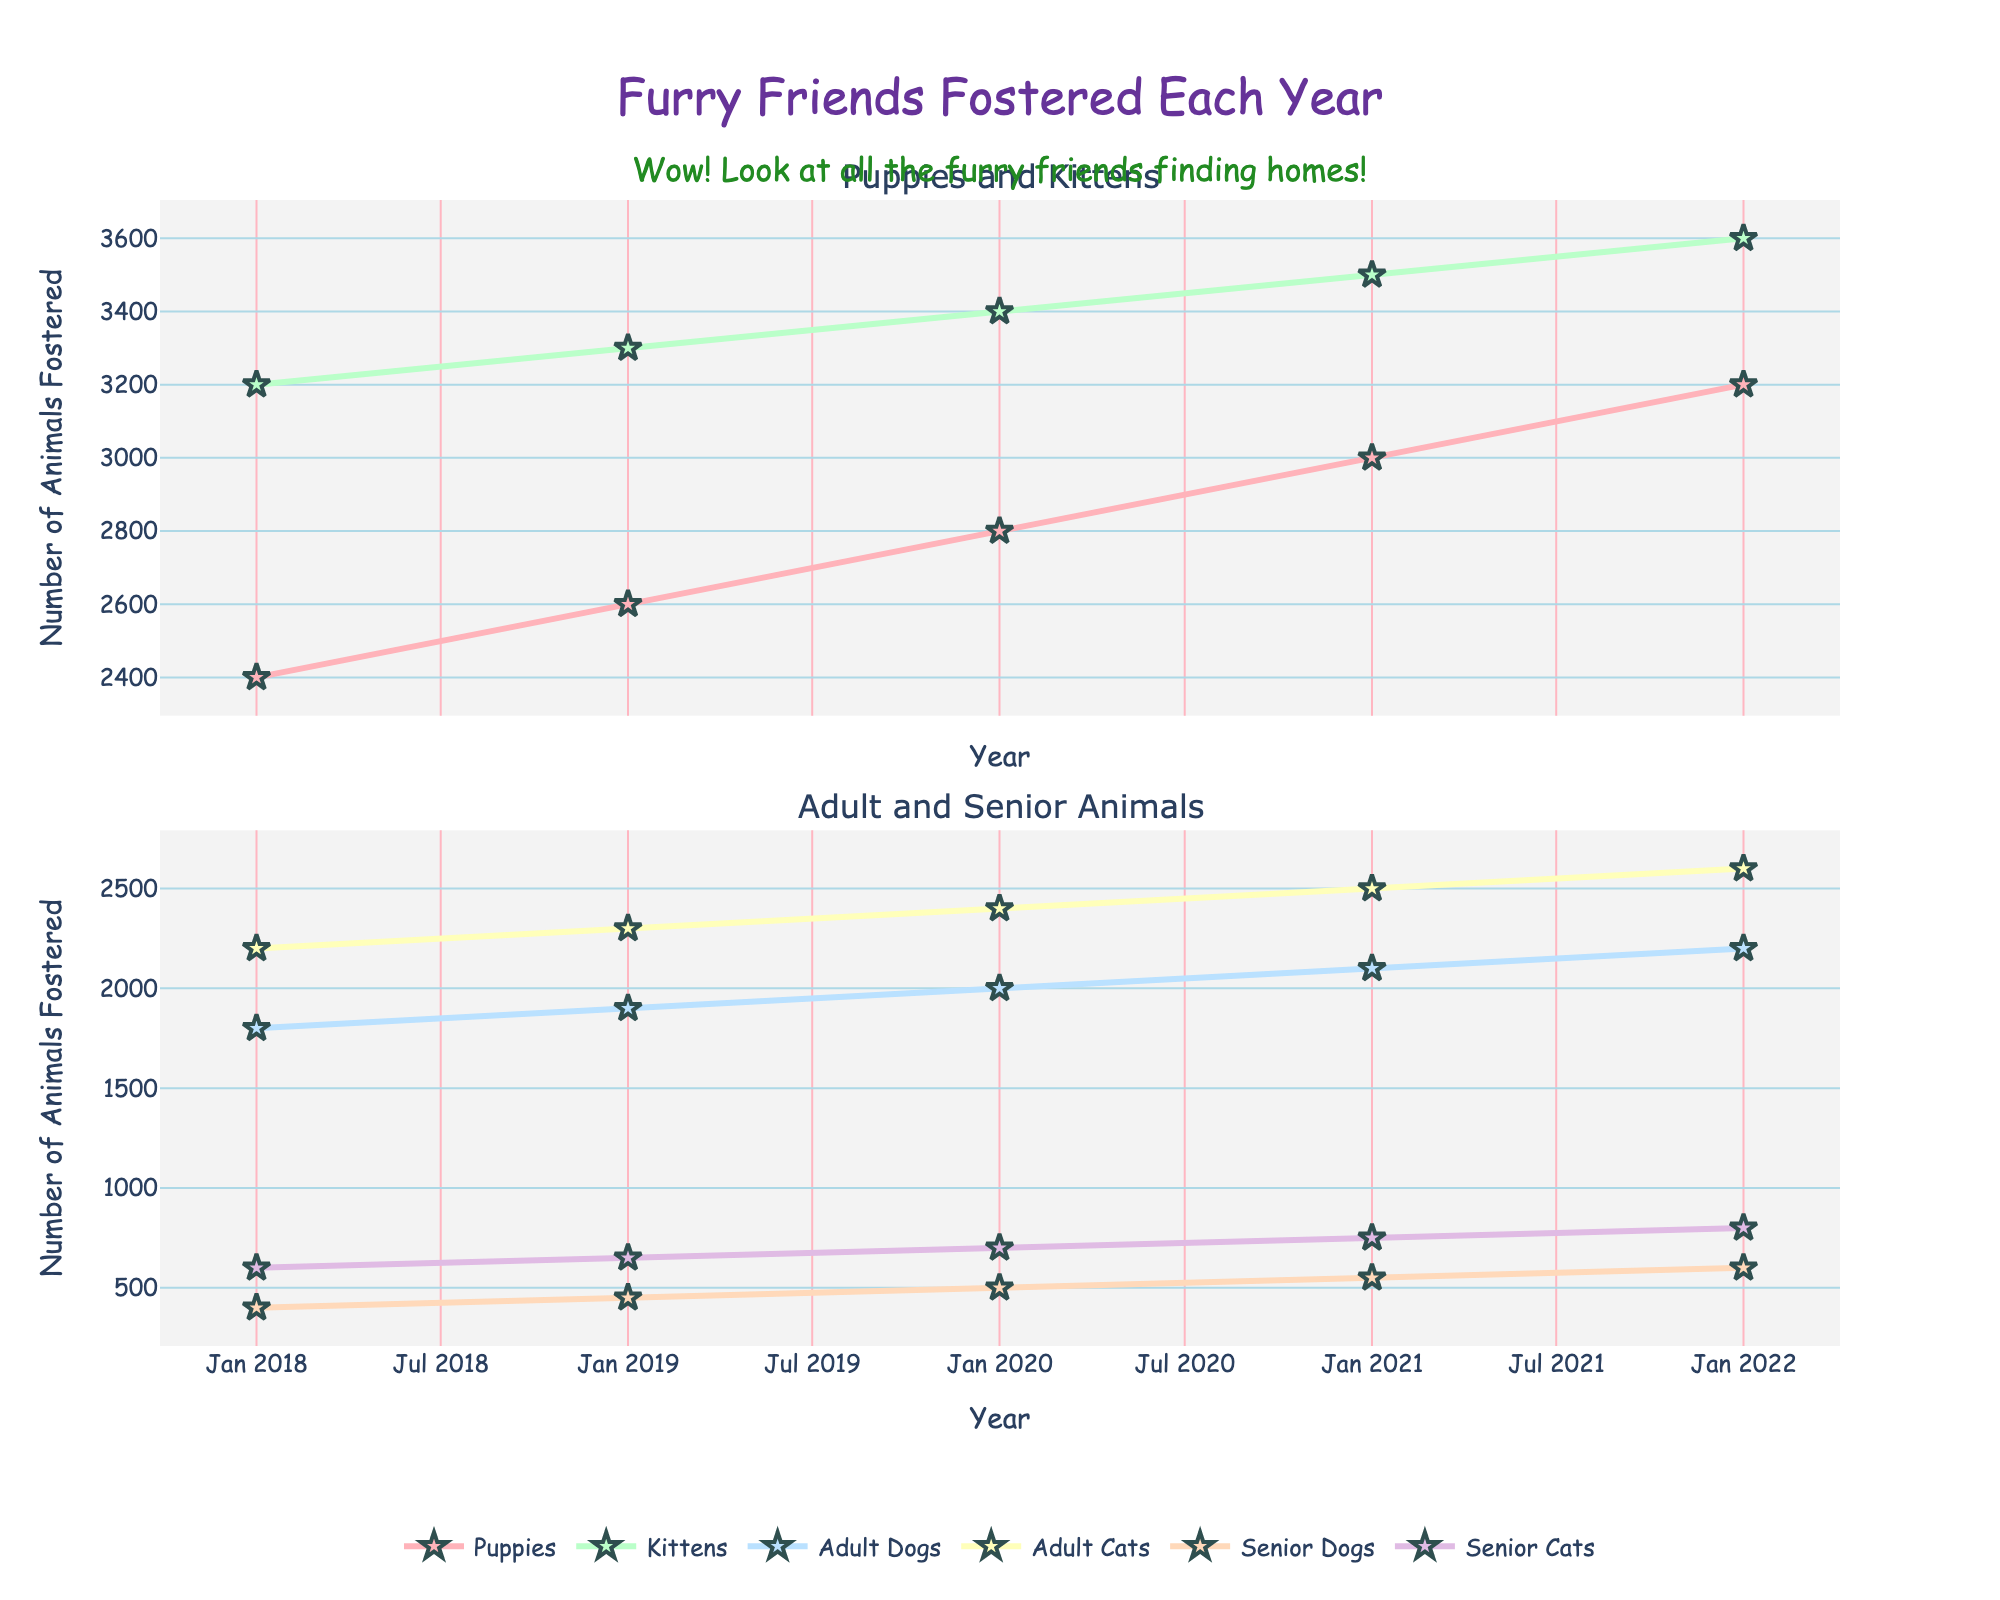How many animals were fostered in 2018? Adding up all the numbers for 2018: 2400 (Puppies) + 3200 (Kittens) + 1800 (Adult Dogs) + 2200 (Adult Cats) + 400 (Senior Dogs) + 600 (Senior Cats) = 10600
Answer: 10600 Which year saw the highest number of fostered puppies? Comparing the number of fostered puppies each year, 3200 is the highest and occurred in 2022
Answer: 2022 By how much did the number of fostered kittens increase from 2018 to 2022? Subtracting the number of kittens fostered in 2018 from that in 2022: 3600 (2022) - 3200 (2018) = 400
Answer: 400 In which age group did the number of animals fostered increase the most from 2018 to 2022? Calculating the increase for each group from 2018 to 2022: Puppies: 3200-2400=800, Kittens: 3600-3200=400, Adult Dogs: 2200-1800=400, Adult Cats: 2600-2200=400, Senior Dogs: 600-400=200, Senior Cats: 800-600=200. The highest increase is for Puppies with 800
Answer: Puppies How did the number of fostered senior cats change over the years? Observing the number of fostered senior cats each year: 2018 (600), 2019 (650), 2020 (700), 2021 (750), 2022 (800). The number steadily increased each year.
Answer: Increased steadily Which group had fewer animals fostered in 2020, senior dogs or senior cats? Comparing the numbers for 2020: Senior Dogs (500), Senior Cats (700). Senior Dogs had fewer animals fostered.
Answer: Senior Dogs What is the trend for adult dogs being fostered from 2018 to 2022? Observing the number of adult dogs fostered: 2018 (1800), 2019 (1900), 2020 (2000), 2021 (2100), 2022 (2200). The trend shows a steady increase each year.
Answer: Increasing How many animals were fostered in total in 2021? Adding up all the animals fostered in 2021: 3000 (Puppies) + 3500 (Kittens) + 2100 (Adult Dogs) + 2500 (Adult Cats) + 550 (Senior Dogs) + 750 (Senior Cats) = 12400
Answer: 12400 